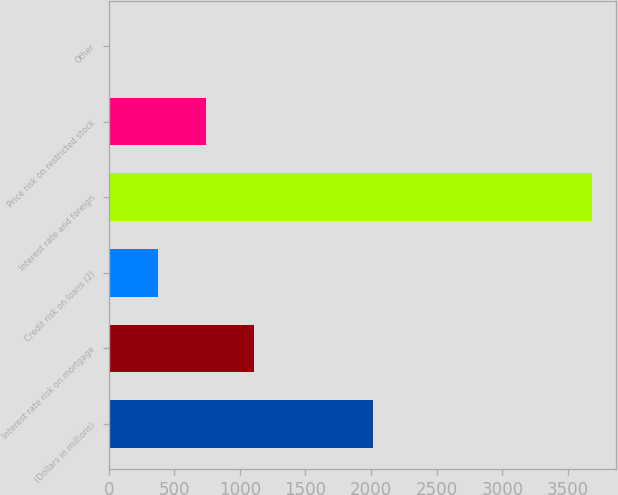Convert chart. <chart><loc_0><loc_0><loc_500><loc_500><bar_chart><fcel>(Dollars in millions)<fcel>Interest rate risk on mortgage<fcel>Credit risk on loans (2)<fcel>Interest rate and foreign<fcel>Price risk on restricted stock<fcel>Other<nl><fcel>2014<fcel>1111.2<fcel>376.4<fcel>3683<fcel>743.8<fcel>9<nl></chart> 